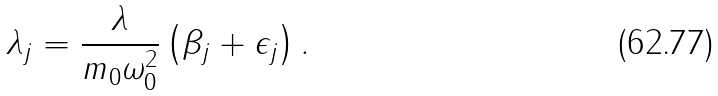Convert formula to latex. <formula><loc_0><loc_0><loc_500><loc_500>\lambda _ { j } = \frac { \lambda } { m _ { 0 } \omega _ { 0 } ^ { 2 } } \left ( \beta _ { j } + \epsilon _ { j } \right ) .</formula> 